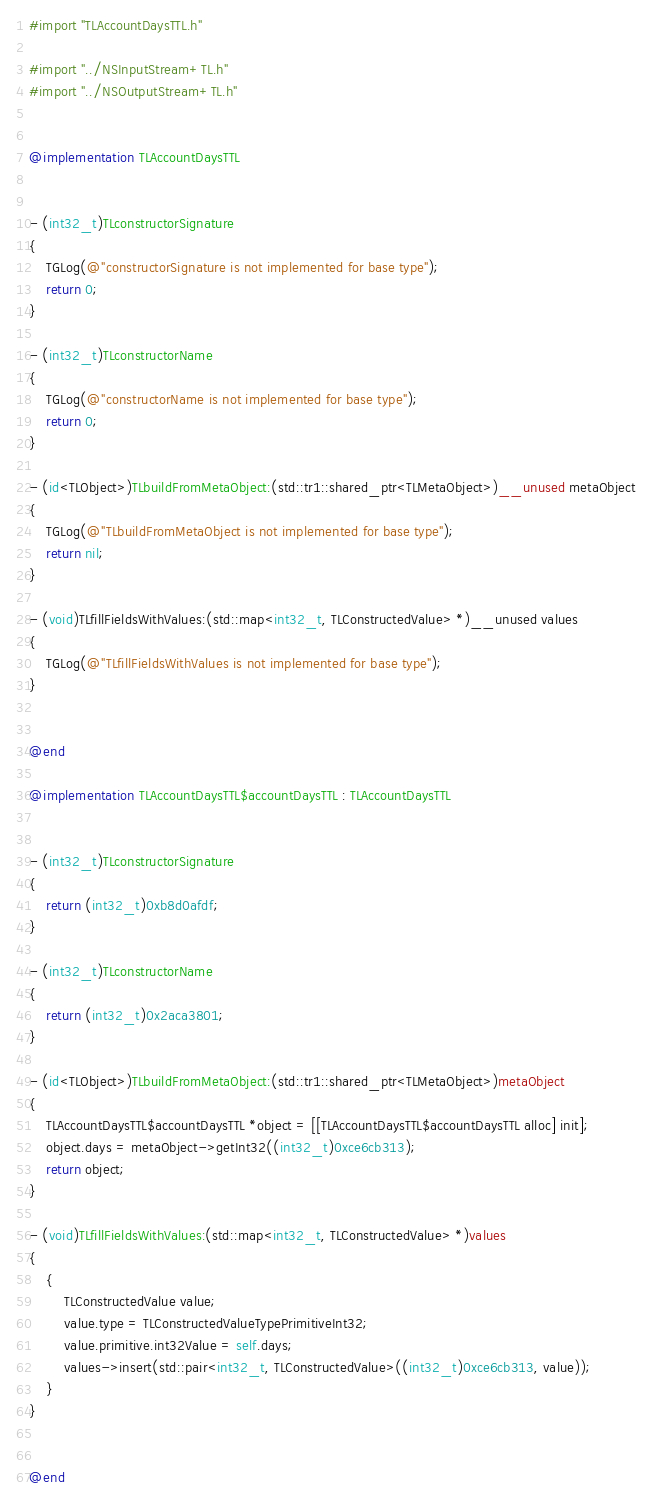<code> <loc_0><loc_0><loc_500><loc_500><_ObjectiveC_>#import "TLAccountDaysTTL.h"

#import "../NSInputStream+TL.h"
#import "../NSOutputStream+TL.h"


@implementation TLAccountDaysTTL


- (int32_t)TLconstructorSignature
{
    TGLog(@"constructorSignature is not implemented for base type");
    return 0;
}

- (int32_t)TLconstructorName
{
    TGLog(@"constructorName is not implemented for base type");
    return 0;
}

- (id<TLObject>)TLbuildFromMetaObject:(std::tr1::shared_ptr<TLMetaObject>)__unused metaObject
{
    TGLog(@"TLbuildFromMetaObject is not implemented for base type");
    return nil;
}

- (void)TLfillFieldsWithValues:(std::map<int32_t, TLConstructedValue> *)__unused values
{
    TGLog(@"TLfillFieldsWithValues is not implemented for base type");
}


@end

@implementation TLAccountDaysTTL$accountDaysTTL : TLAccountDaysTTL


- (int32_t)TLconstructorSignature
{
    return (int32_t)0xb8d0afdf;
}

- (int32_t)TLconstructorName
{
    return (int32_t)0x2aca3801;
}

- (id<TLObject>)TLbuildFromMetaObject:(std::tr1::shared_ptr<TLMetaObject>)metaObject
{
    TLAccountDaysTTL$accountDaysTTL *object = [[TLAccountDaysTTL$accountDaysTTL alloc] init];
    object.days = metaObject->getInt32((int32_t)0xce6cb313);
    return object;
}

- (void)TLfillFieldsWithValues:(std::map<int32_t, TLConstructedValue> *)values
{
    {
        TLConstructedValue value;
        value.type = TLConstructedValueTypePrimitiveInt32;
        value.primitive.int32Value = self.days;
        values->insert(std::pair<int32_t, TLConstructedValue>((int32_t)0xce6cb313, value));
    }
}


@end

</code> 